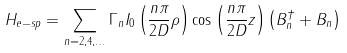<formula> <loc_0><loc_0><loc_500><loc_500>H _ { e - s p } = \sum _ { n = 2 , 4 , \dots } \Gamma _ { n } I _ { 0 } \left ( \frac { n \pi } { 2 D } \rho \right ) \cos \left ( \frac { n \pi } { 2 D } z \right ) \left ( B _ { n } ^ { \dag } + B _ { n } \right )</formula> 